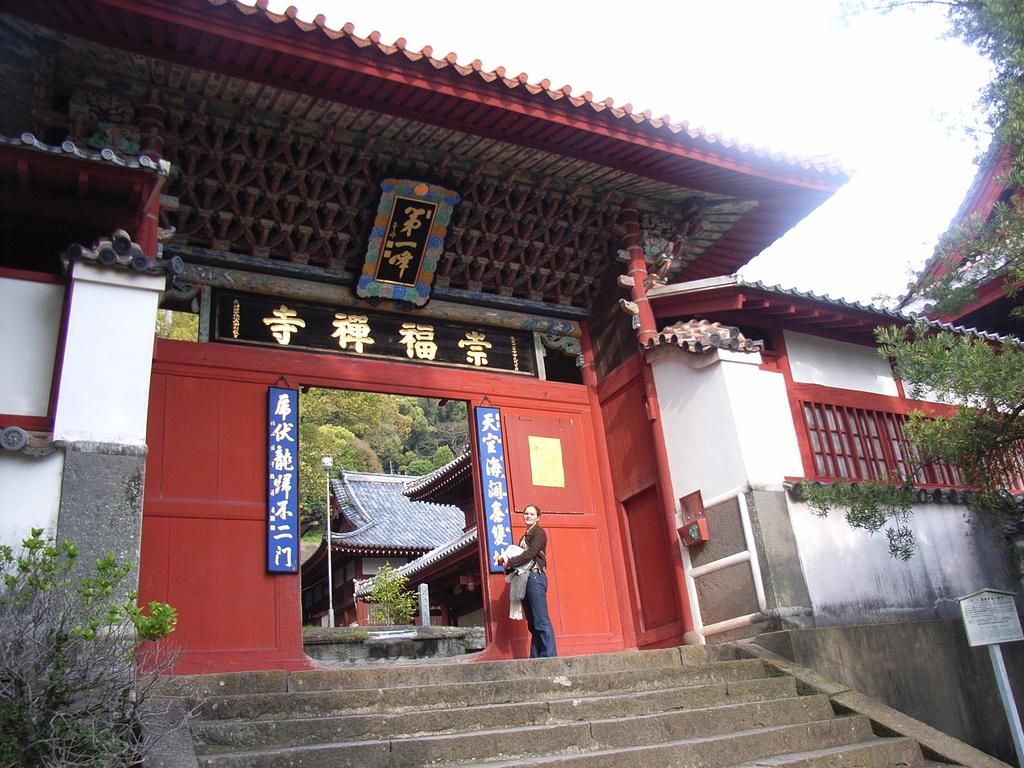What type of structure can be seen in the image? There are stairs, a board, a wooden gate, and a house visible in the image. What type of vegetation is present in the image? There are plants and trees visible in the image. Can you describe the person standing in the image? There is a person standing in the image, but no specific details about their appearance or actions are provided. What is the background of the image like? The background of the image includes trees and the sky. What type of relation does the person standing in the image have with the lumber? There is no lumber present in the image, and therefore no relation can be established between the person and lumber. What type of meeting is taking place in the image? There is no indication of a meeting taking place in the image. 